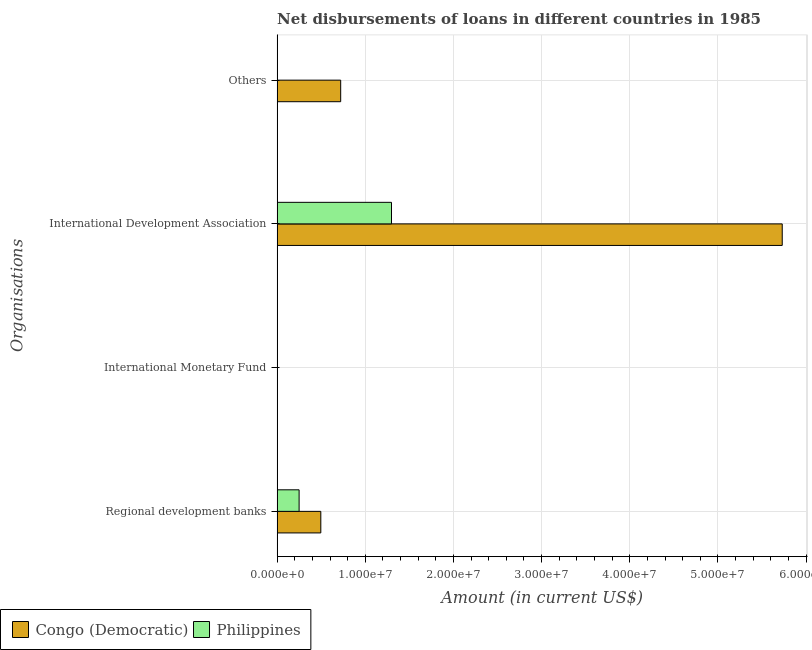Are the number of bars per tick equal to the number of legend labels?
Make the answer very short. No. Are the number of bars on each tick of the Y-axis equal?
Your answer should be compact. No. How many bars are there on the 2nd tick from the top?
Offer a terse response. 2. What is the label of the 1st group of bars from the top?
Keep it short and to the point. Others. What is the amount of loan disimbursed by international monetary fund in Congo (Democratic)?
Offer a very short reply. 0. Across all countries, what is the maximum amount of loan disimbursed by regional development banks?
Your response must be concise. 4.96e+06. In which country was the amount of loan disimbursed by regional development banks maximum?
Ensure brevity in your answer.  Congo (Democratic). What is the total amount of loan disimbursed by international development association in the graph?
Offer a terse response. 7.03e+07. What is the difference between the amount of loan disimbursed by international development association in Congo (Democratic) and that in Philippines?
Provide a succinct answer. 4.43e+07. What is the average amount of loan disimbursed by international monetary fund per country?
Offer a terse response. 0. What is the difference between the amount of loan disimbursed by international development association and amount of loan disimbursed by other organisations in Congo (Democratic)?
Provide a short and direct response. 5.01e+07. What is the ratio of the amount of loan disimbursed by regional development banks in Philippines to that in Congo (Democratic)?
Your answer should be very brief. 0.5. What is the difference between the highest and the second highest amount of loan disimbursed by international development association?
Provide a succinct answer. 4.43e+07. What is the difference between the highest and the lowest amount of loan disimbursed by regional development banks?
Your answer should be compact. 2.46e+06. In how many countries, is the amount of loan disimbursed by international development association greater than the average amount of loan disimbursed by international development association taken over all countries?
Make the answer very short. 1. Is the sum of the amount of loan disimbursed by international development association in Philippines and Congo (Democratic) greater than the maximum amount of loan disimbursed by international monetary fund across all countries?
Offer a terse response. Yes. Is it the case that in every country, the sum of the amount of loan disimbursed by international monetary fund and amount of loan disimbursed by other organisations is greater than the sum of amount of loan disimbursed by regional development banks and amount of loan disimbursed by international development association?
Keep it short and to the point. No. How many bars are there?
Your answer should be very brief. 5. Are all the bars in the graph horizontal?
Your response must be concise. Yes. What is the difference between two consecutive major ticks on the X-axis?
Provide a short and direct response. 1.00e+07. Are the values on the major ticks of X-axis written in scientific E-notation?
Ensure brevity in your answer.  Yes. Does the graph contain any zero values?
Offer a terse response. Yes. Where does the legend appear in the graph?
Your response must be concise. Bottom left. How are the legend labels stacked?
Your answer should be compact. Horizontal. What is the title of the graph?
Your response must be concise. Net disbursements of loans in different countries in 1985. What is the label or title of the X-axis?
Make the answer very short. Amount (in current US$). What is the label or title of the Y-axis?
Make the answer very short. Organisations. What is the Amount (in current US$) of Congo (Democratic) in Regional development banks?
Your answer should be compact. 4.96e+06. What is the Amount (in current US$) of Philippines in Regional development banks?
Provide a succinct answer. 2.49e+06. What is the Amount (in current US$) in Philippines in International Monetary Fund?
Ensure brevity in your answer.  0. What is the Amount (in current US$) in Congo (Democratic) in International Development Association?
Give a very brief answer. 5.73e+07. What is the Amount (in current US$) of Philippines in International Development Association?
Ensure brevity in your answer.  1.30e+07. What is the Amount (in current US$) in Congo (Democratic) in Others?
Give a very brief answer. 7.21e+06. What is the Amount (in current US$) in Philippines in Others?
Make the answer very short. 0. Across all Organisations, what is the maximum Amount (in current US$) of Congo (Democratic)?
Make the answer very short. 5.73e+07. Across all Organisations, what is the maximum Amount (in current US$) in Philippines?
Keep it short and to the point. 1.30e+07. Across all Organisations, what is the minimum Amount (in current US$) in Philippines?
Provide a short and direct response. 0. What is the total Amount (in current US$) in Congo (Democratic) in the graph?
Your response must be concise. 6.95e+07. What is the total Amount (in current US$) of Philippines in the graph?
Ensure brevity in your answer.  1.55e+07. What is the difference between the Amount (in current US$) of Congo (Democratic) in Regional development banks and that in International Development Association?
Give a very brief answer. -5.23e+07. What is the difference between the Amount (in current US$) in Philippines in Regional development banks and that in International Development Association?
Ensure brevity in your answer.  -1.05e+07. What is the difference between the Amount (in current US$) in Congo (Democratic) in Regional development banks and that in Others?
Your answer should be very brief. -2.25e+06. What is the difference between the Amount (in current US$) of Congo (Democratic) in International Development Association and that in Others?
Ensure brevity in your answer.  5.01e+07. What is the difference between the Amount (in current US$) of Congo (Democratic) in Regional development banks and the Amount (in current US$) of Philippines in International Development Association?
Give a very brief answer. -8.02e+06. What is the average Amount (in current US$) of Congo (Democratic) per Organisations?
Offer a terse response. 1.74e+07. What is the average Amount (in current US$) of Philippines per Organisations?
Provide a short and direct response. 3.87e+06. What is the difference between the Amount (in current US$) of Congo (Democratic) and Amount (in current US$) of Philippines in Regional development banks?
Your answer should be very brief. 2.46e+06. What is the difference between the Amount (in current US$) in Congo (Democratic) and Amount (in current US$) in Philippines in International Development Association?
Offer a terse response. 4.43e+07. What is the ratio of the Amount (in current US$) in Congo (Democratic) in Regional development banks to that in International Development Association?
Ensure brevity in your answer.  0.09. What is the ratio of the Amount (in current US$) of Philippines in Regional development banks to that in International Development Association?
Your answer should be very brief. 0.19. What is the ratio of the Amount (in current US$) of Congo (Democratic) in Regional development banks to that in Others?
Keep it short and to the point. 0.69. What is the ratio of the Amount (in current US$) in Congo (Democratic) in International Development Association to that in Others?
Provide a short and direct response. 7.95. What is the difference between the highest and the second highest Amount (in current US$) in Congo (Democratic)?
Give a very brief answer. 5.01e+07. What is the difference between the highest and the lowest Amount (in current US$) in Congo (Democratic)?
Keep it short and to the point. 5.73e+07. What is the difference between the highest and the lowest Amount (in current US$) in Philippines?
Your answer should be compact. 1.30e+07. 